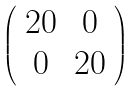<formula> <loc_0><loc_0><loc_500><loc_500>\left ( \begin{array} { c c } 2 0 & 0 \\ 0 & 2 0 \\ \end{array} \right )</formula> 